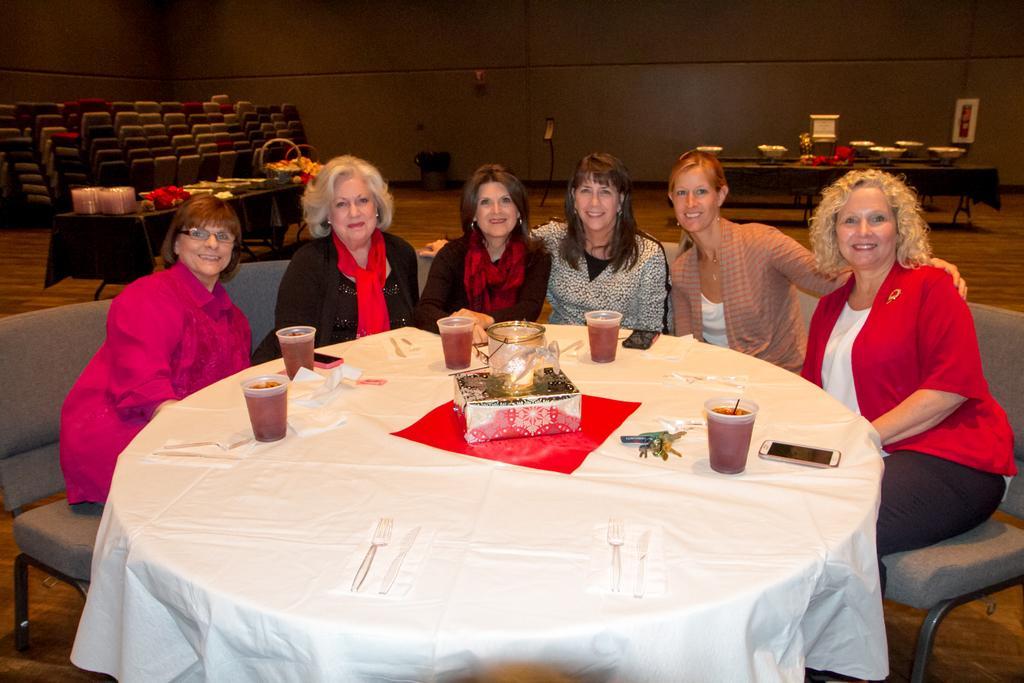How would you summarize this image in a sentence or two? In this image I see 6 women sitting on the couch and all of them are smiling and there is a table in front of them and there are glasses and few phones on it. In the background I see the chairs and 2 tables and few things on it. 